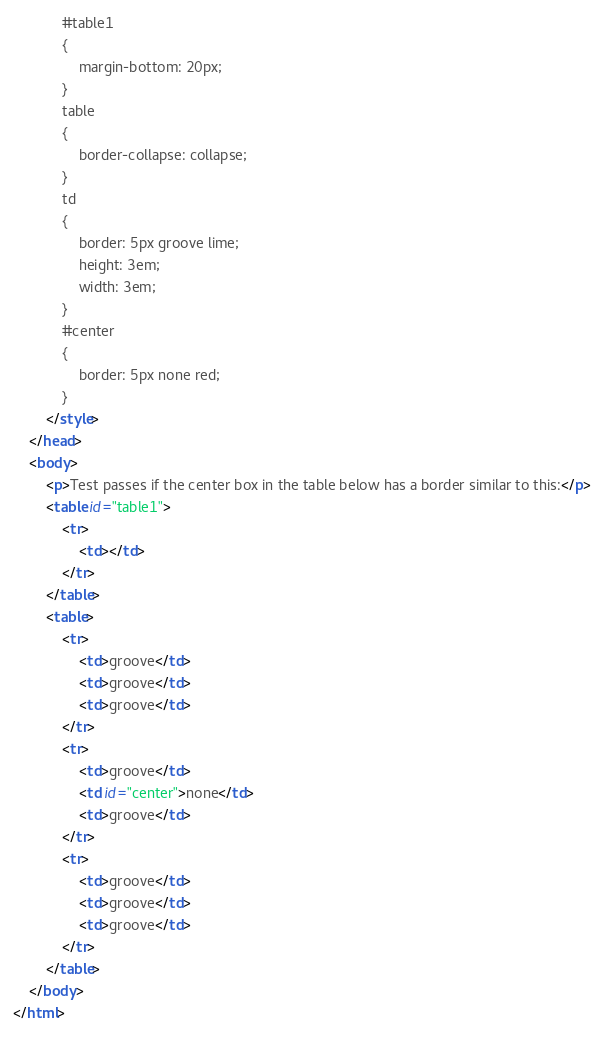Convert code to text. <code><loc_0><loc_0><loc_500><loc_500><_HTML_>            #table1
            {
                margin-bottom: 20px;
            }
            table
            {
                border-collapse: collapse;
            }
            td
            {
                border: 5px groove lime;
                height: 3em;
                width: 3em;
            }
            #center
            {
                border: 5px none red;
            }
        </style>
    </head>
    <body>
        <p>Test passes if the center box in the table below has a border similar to this:</p>
        <table id="table1">
            <tr>
                <td></td>
            </tr>
        </table>
        <table>
            <tr>
                <td>groove</td>
                <td>groove</td>
                <td>groove</td>
            </tr>
            <tr>
                <td>groove</td>
                <td id="center">none</td>
                <td>groove</td>
            </tr>
            <tr>
                <td>groove</td>
                <td>groove</td>
                <td>groove</td>
            </tr>
        </table>
    </body>
</html></code> 